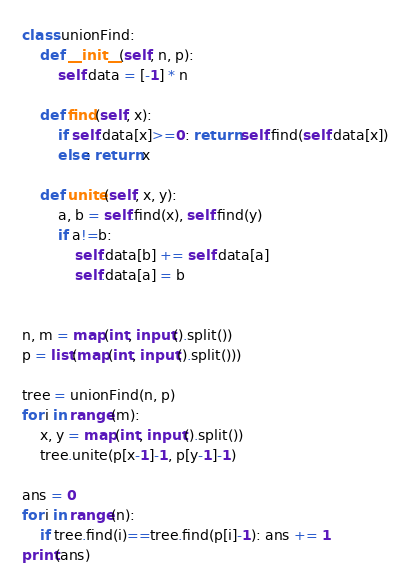<code> <loc_0><loc_0><loc_500><loc_500><_Python_>class unionFind:
    def __init__(self, n, p):
        self.data = [-1] * n

    def find(self, x):
        if self.data[x]>=0: return self.find(self.data[x])
        else: return x

    def unite(self, x, y):
        a, b = self.find(x), self.find(y)
        if a!=b:
            self.data[b] += self.data[a]
            self.data[a] = b


n, m = map(int, input().split())
p = list(map(int, input().split()))

tree = unionFind(n, p)
for i in range(m):
    x, y = map(int, input().split())
    tree.unite(p[x-1]-1, p[y-1]-1)

ans = 0
for i in range(n):
    if tree.find(i)==tree.find(p[i]-1): ans += 1
print(ans)</code> 